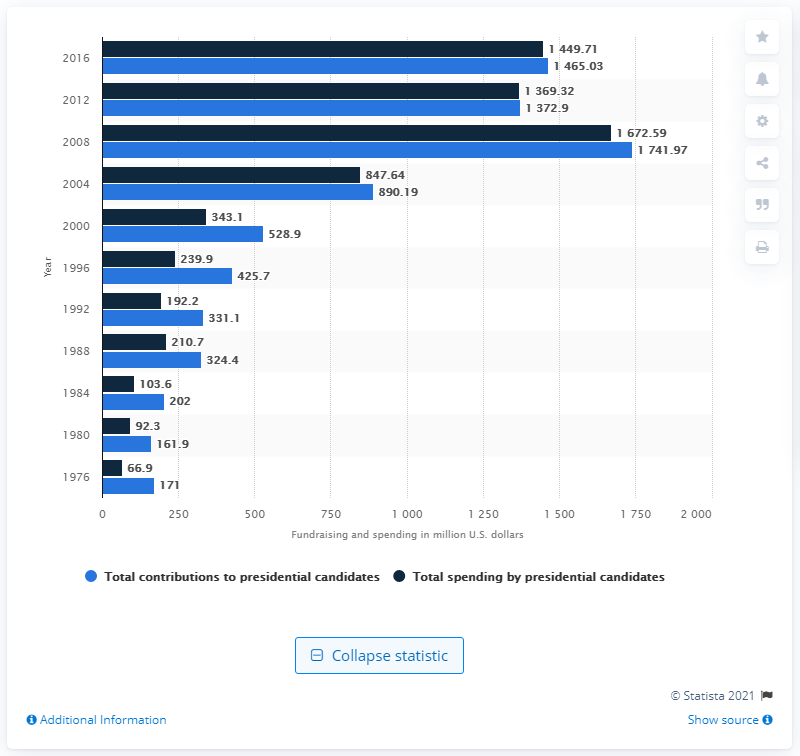Highlight a few significant elements in this photo. The highest blue bar appeared in 2008. In 2012, a total of $1,372.90 was spent on presidential candidates. In the year 1980, the lowest blue bar was present. The amount of money spent on presidential candidates in 2012 was $1,372.9 million. 